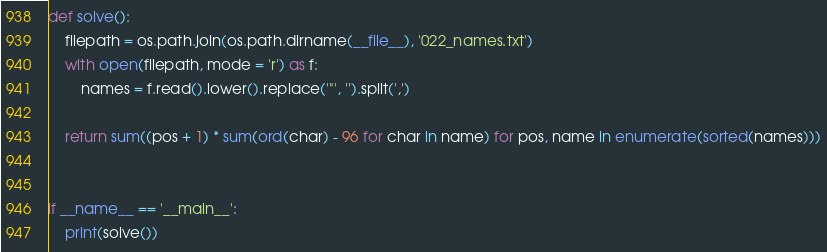Convert code to text. <code><loc_0><loc_0><loc_500><loc_500><_Python_>


def solve():
    filepath = os.path.join(os.path.dirname(__file__), '022_names.txt')
    with open(filepath, mode = 'r') as f:
        names = f.read().lower().replace('"', '').split(',')

    return sum((pos + 1) * sum(ord(char) - 96 for char in name) for pos, name in enumerate(sorted(names)))


if __name__ == '__main__':
    print(solve())
</code> 